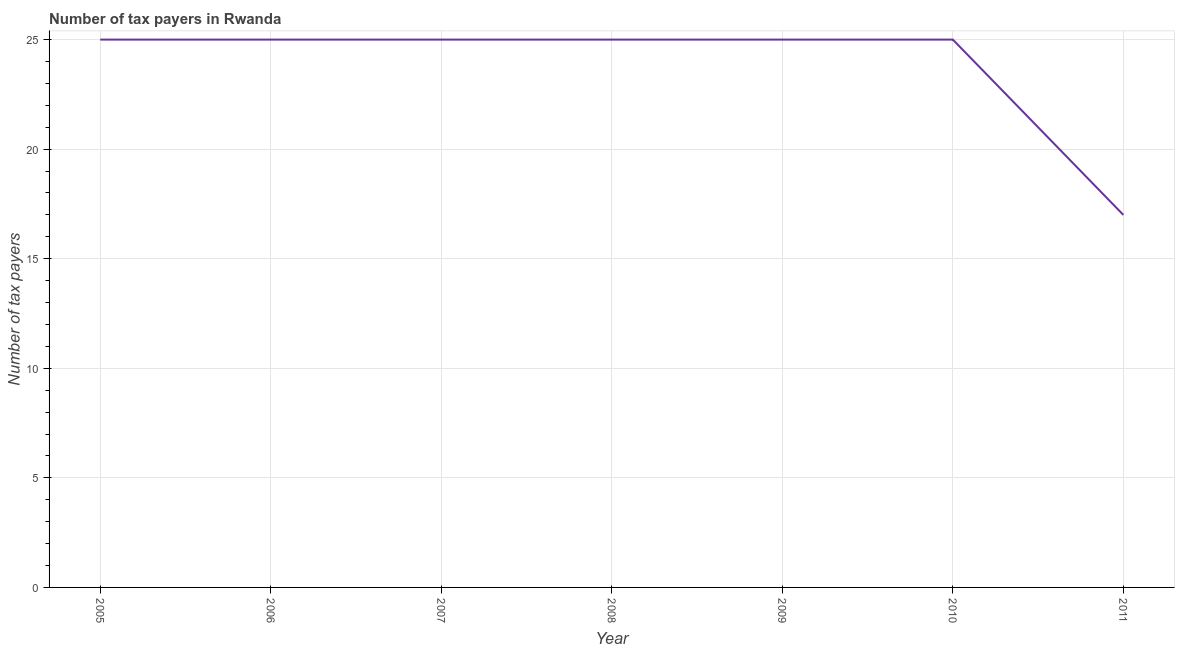What is the number of tax payers in 2008?
Offer a very short reply. 25. Across all years, what is the maximum number of tax payers?
Your answer should be compact. 25. Across all years, what is the minimum number of tax payers?
Offer a very short reply. 17. In which year was the number of tax payers maximum?
Keep it short and to the point. 2005. What is the sum of the number of tax payers?
Provide a short and direct response. 167. What is the average number of tax payers per year?
Your answer should be very brief. 23.86. What is the median number of tax payers?
Provide a succinct answer. 25. What is the ratio of the number of tax payers in 2006 to that in 2009?
Give a very brief answer. 1. What is the difference between the highest and the lowest number of tax payers?
Ensure brevity in your answer.  8. In how many years, is the number of tax payers greater than the average number of tax payers taken over all years?
Offer a very short reply. 6. Does the number of tax payers monotonically increase over the years?
Provide a succinct answer. No. Does the graph contain grids?
Provide a short and direct response. Yes. What is the title of the graph?
Your answer should be compact. Number of tax payers in Rwanda. What is the label or title of the Y-axis?
Offer a terse response. Number of tax payers. What is the Number of tax payers of 2007?
Provide a short and direct response. 25. What is the Number of tax payers in 2008?
Give a very brief answer. 25. What is the Number of tax payers of 2010?
Give a very brief answer. 25. What is the difference between the Number of tax payers in 2005 and 2006?
Keep it short and to the point. 0. What is the difference between the Number of tax payers in 2005 and 2007?
Make the answer very short. 0. What is the difference between the Number of tax payers in 2005 and 2008?
Your answer should be compact. 0. What is the difference between the Number of tax payers in 2005 and 2010?
Keep it short and to the point. 0. What is the difference between the Number of tax payers in 2005 and 2011?
Provide a succinct answer. 8. What is the difference between the Number of tax payers in 2006 and 2007?
Ensure brevity in your answer.  0. What is the difference between the Number of tax payers in 2006 and 2009?
Ensure brevity in your answer.  0. What is the difference between the Number of tax payers in 2006 and 2010?
Offer a very short reply. 0. What is the difference between the Number of tax payers in 2007 and 2008?
Provide a short and direct response. 0. What is the difference between the Number of tax payers in 2007 and 2010?
Ensure brevity in your answer.  0. What is the difference between the Number of tax payers in 2007 and 2011?
Offer a very short reply. 8. What is the difference between the Number of tax payers in 2008 and 2009?
Offer a very short reply. 0. What is the difference between the Number of tax payers in 2008 and 2010?
Give a very brief answer. 0. What is the difference between the Number of tax payers in 2009 and 2011?
Provide a short and direct response. 8. What is the ratio of the Number of tax payers in 2005 to that in 2007?
Your answer should be compact. 1. What is the ratio of the Number of tax payers in 2005 to that in 2011?
Offer a very short reply. 1.47. What is the ratio of the Number of tax payers in 2006 to that in 2007?
Offer a terse response. 1. What is the ratio of the Number of tax payers in 2006 to that in 2011?
Provide a succinct answer. 1.47. What is the ratio of the Number of tax payers in 2007 to that in 2008?
Provide a short and direct response. 1. What is the ratio of the Number of tax payers in 2007 to that in 2010?
Offer a terse response. 1. What is the ratio of the Number of tax payers in 2007 to that in 2011?
Provide a short and direct response. 1.47. What is the ratio of the Number of tax payers in 2008 to that in 2009?
Your answer should be very brief. 1. What is the ratio of the Number of tax payers in 2008 to that in 2010?
Make the answer very short. 1. What is the ratio of the Number of tax payers in 2008 to that in 2011?
Offer a terse response. 1.47. What is the ratio of the Number of tax payers in 2009 to that in 2011?
Give a very brief answer. 1.47. What is the ratio of the Number of tax payers in 2010 to that in 2011?
Your answer should be very brief. 1.47. 